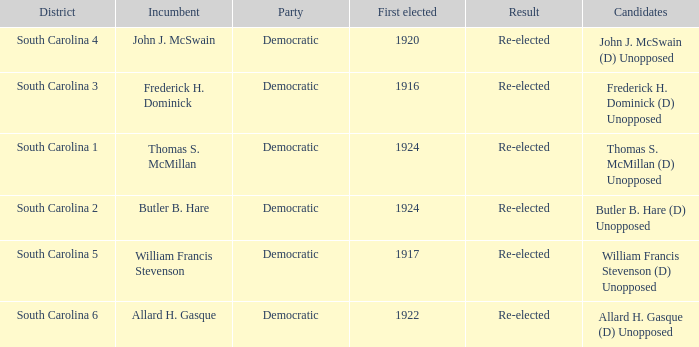What is the result for south carolina 4? Re-elected. 